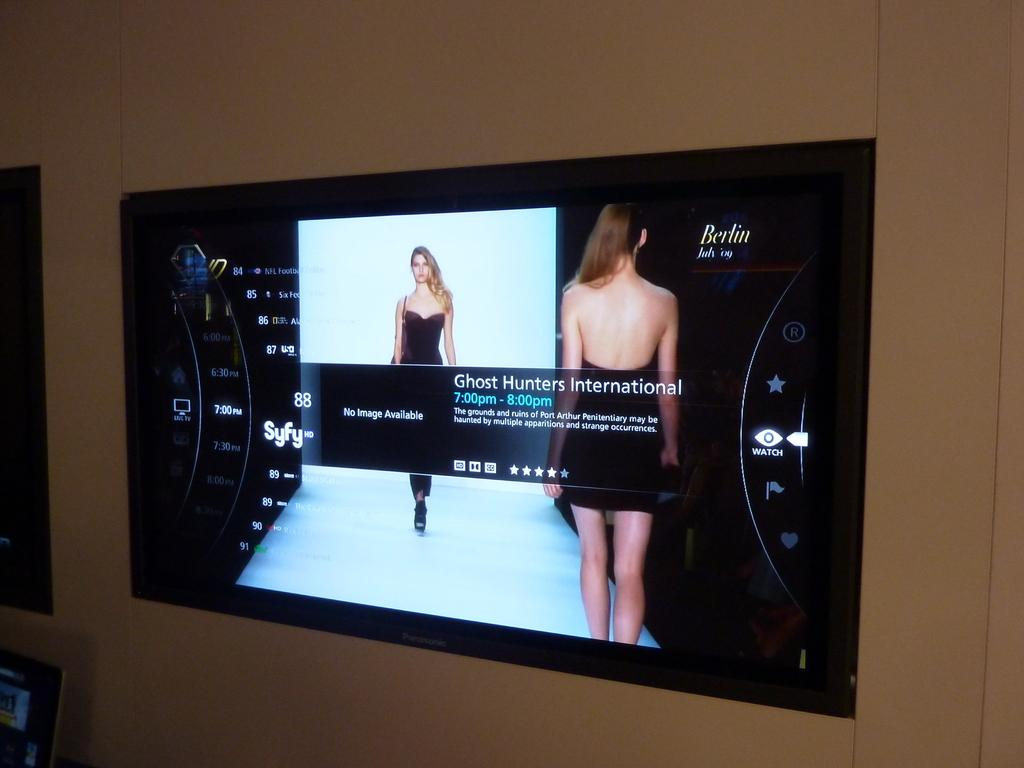<image>
Summarize the visual content of the image. A flat screen with a picture of a model and the text No Image Available visible. 